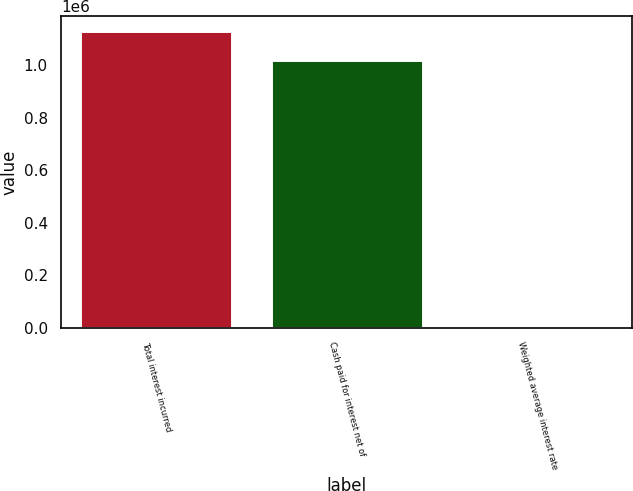Convert chart. <chart><loc_0><loc_0><loc_500><loc_500><bar_chart><fcel>Total interest incurred<fcel>Cash paid for interest net of<fcel>Weighted average interest rate<nl><fcel>1.1314e+06<fcel>1.02004e+06<fcel>8<nl></chart> 